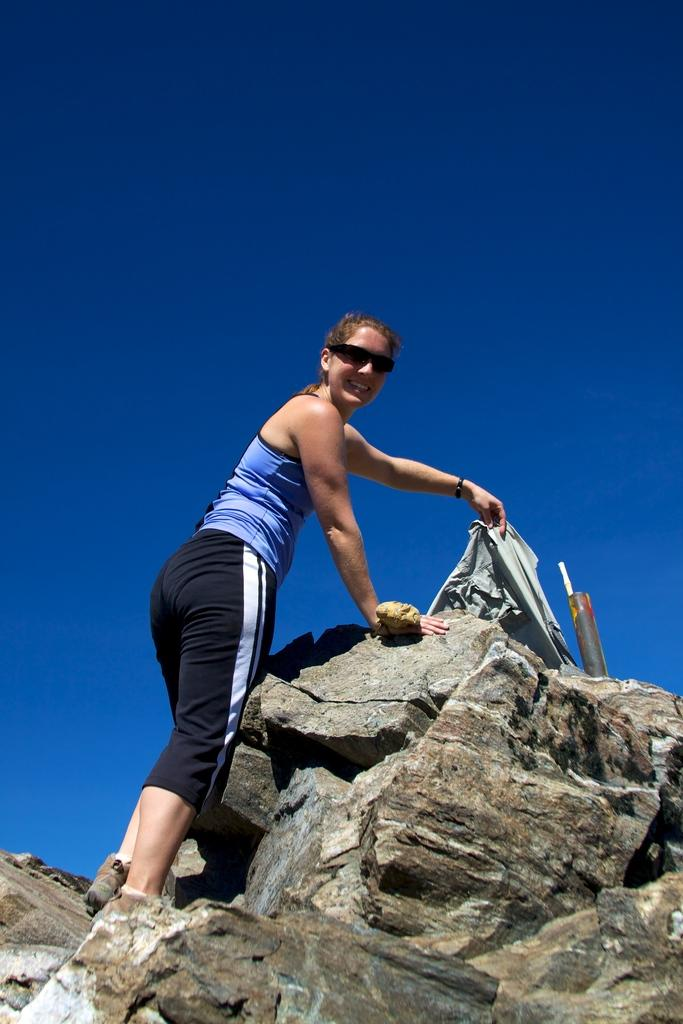Who is the main subject in the image? There is a lady in the center of the image. What is the lady standing on? The lady is standing on a rock. What is the lady wearing? The lady is wearing glasses. What is the lady holding? The lady is holding a shirt. What else can be seen in the image besides the lady? There are other objects visible in the image. What is visible at the top of the image? The sky is visible at the top of the image. Where is the hen located in the image? There is no hen present in the image. What type of honey is being collected by the lady in the image? There is no honey or honey collection activity depicted in the image. 